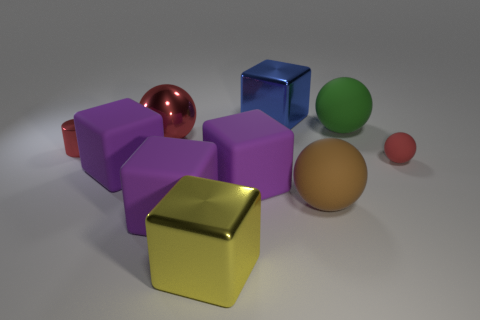How many purple cubes must be subtracted to get 1 purple cubes? 2 Subtract all purple cylinders. How many purple cubes are left? 3 Subtract 1 blocks. How many blocks are left? 4 Subtract all yellow cubes. How many cubes are left? 4 Subtract all yellow metallic blocks. How many blocks are left? 4 Subtract all cyan cubes. Subtract all gray cylinders. How many cubes are left? 5 Subtract all spheres. How many objects are left? 6 Add 7 tiny purple rubber balls. How many tiny purple rubber balls exist? 7 Subtract 0 green cylinders. How many objects are left? 10 Subtract all large balls. Subtract all big blue metallic cubes. How many objects are left? 6 